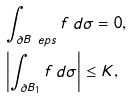<formula> <loc_0><loc_0><loc_500><loc_500>& \int _ { \partial B _ { \ } e p s } f \, d \sigma = 0 , \\ & \left | \int _ { \partial B _ { 1 } } f \, d \sigma \right | \leq K , \\</formula> 